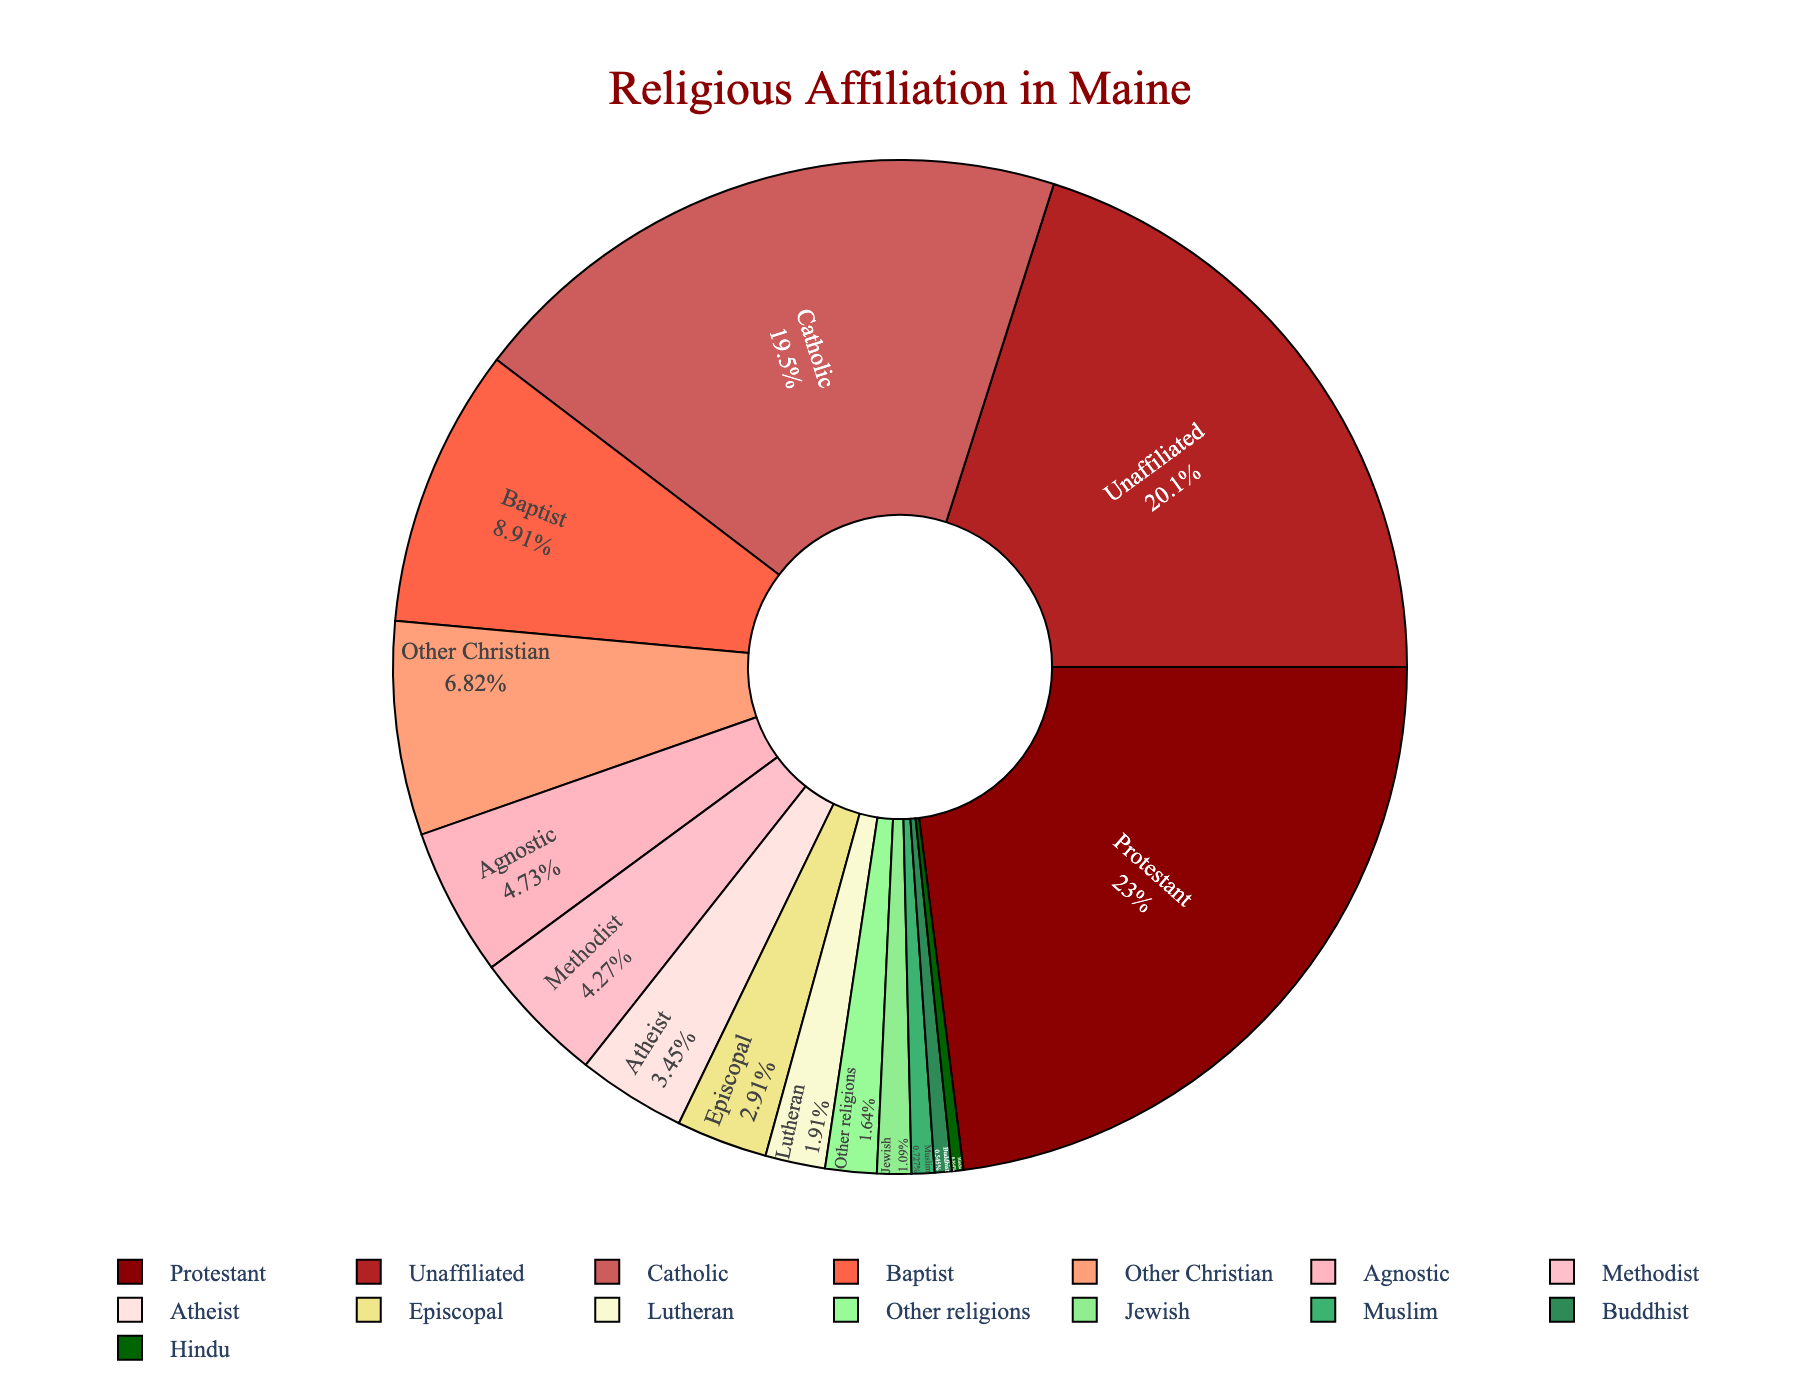What percentage of people are affiliated with Christian denominations including Catholic in Maine? To find the total percentage of people affiliated with Christian denominations, add up the percentages of Catholic, Protestant, Baptist, Methodist, Lutheran, Episcopal, and Other Christian.
Calculation: 21.5 + 25.3 + 9.8 + 4.7 + 2.1 + 3.2 + 7.5 = 74.1%
Answer: 74.1% How does the percentage of Catholic affiliation compare to the percentage of Protestant affiliation? The percentage of Catholic affiliation is 21.5%, and the percentage of Protestant affiliation is 25.3%. Comparing these values, Protestant affiliation is higher than Catholic affiliation in Maine.
Answer: Protestant affiliation is higher Which group has the smallest percentage and what is it? The group with the smallest percentage is Hindu, with a percentage of 0.4%.
Answer: Hindu, 0.4% What is the difference between the percentage of Atheists and Agnostics? The percentage of Atheists is 3.8%, and the percentage of Agnostics is 5.2%. 
Difference: 5.2 - 3.8 = 1.4%
Answer: 1.4% What is the combined percentage for non-Christian religions (Jewish, Muslim, Buddhist, Hindu)? Add the percentages for Jewish, Muslim, Buddhist, and Hindu.
Calculation: 1.2 + 0.8 + 0.6 + 0.4 = 3.0%
Answer: 3.0% Which color represents Catholic affiliation? By visual inspection, locate the segment labeled "Catholic" and identify its color. The color representing Catholic affiliation is a shade of dark red.
Answer: Dark red How much larger is the percentage of unaffiliated individuals compared to Methodists? The percentage of unaffiliated individuals is 22.1%, and the percentage of Methodists is 4.7%.
Difference: 22.1 - 4.7 = 17.4%
Answer: 17.4% What is the most prominent religious affiliation in Maine? The section with the largest percentage value represents the most prominent religious affiliation. By observing the figure, Protestant is the most prominent with 25.3%.
Answer: Protestant, 25.3% 